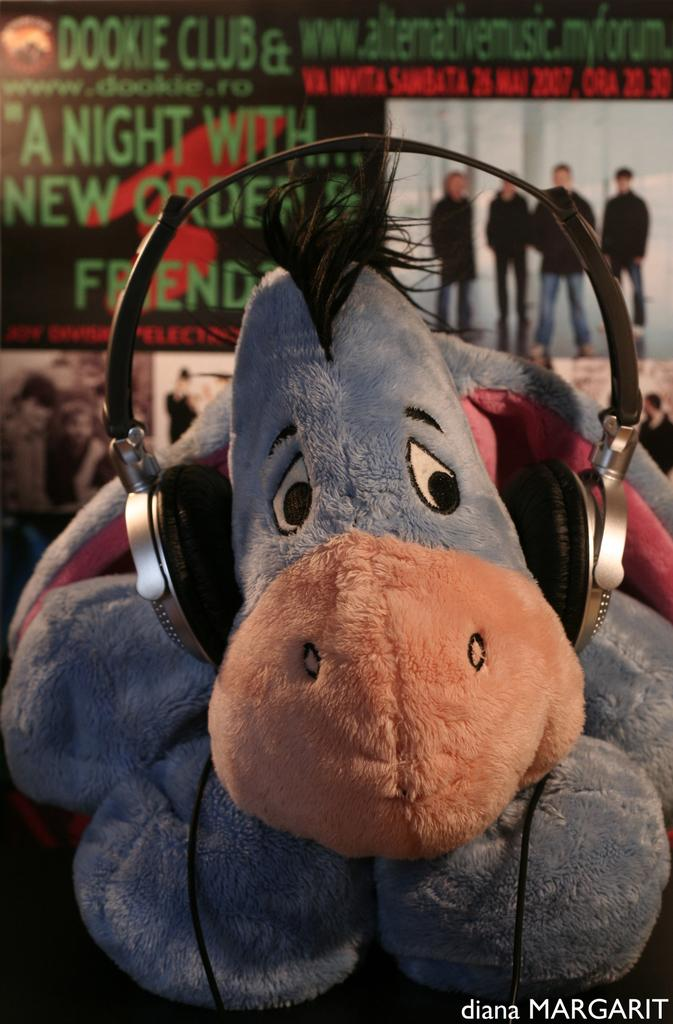What object can be seen in the image? There is a toy in the image. What is the toy wearing? The toy is wearing a headset. What can be seen in the background of the image? There is a poster in the background of the image. What is happening on the poster? There are people standing on the poster. What else can be seen on the poster? There is text or writing on the poster. How does the toy open the door in the image? There is no door present in the image, and the toy is not shown interacting with any door. 